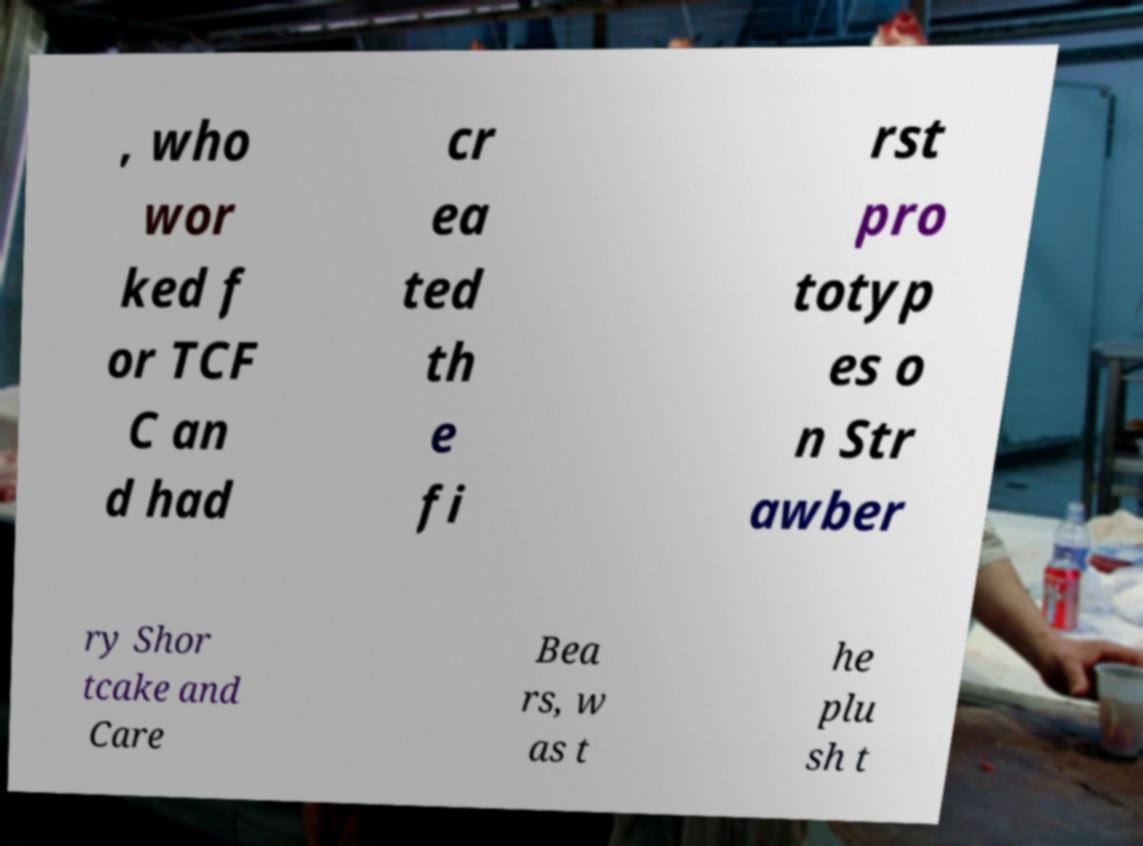Can you accurately transcribe the text from the provided image for me? , who wor ked f or TCF C an d had cr ea ted th e fi rst pro totyp es o n Str awber ry Shor tcake and Care Bea rs, w as t he plu sh t 